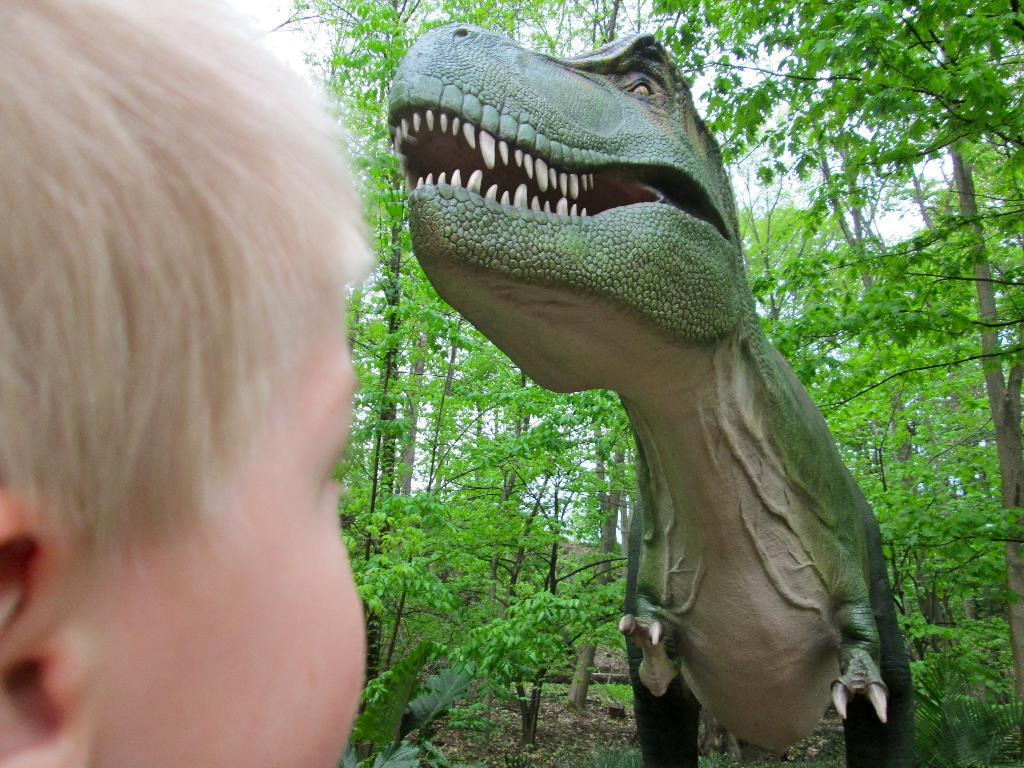What is the main subject of the image? There is a sculpture in the image. Are there any people in the image? Yes, there is a kid in the image. What type of natural environment is visible in the image? Trees are visible in the image. What is visible in the background of the image? The sky is visible in the image. What type of ticket is the kid holding in the image? There is no ticket present in the image; the kid is not holding anything. What book is the kid reading in the image? There is no book present in the image; the kid is not engaged in any reading activity. 